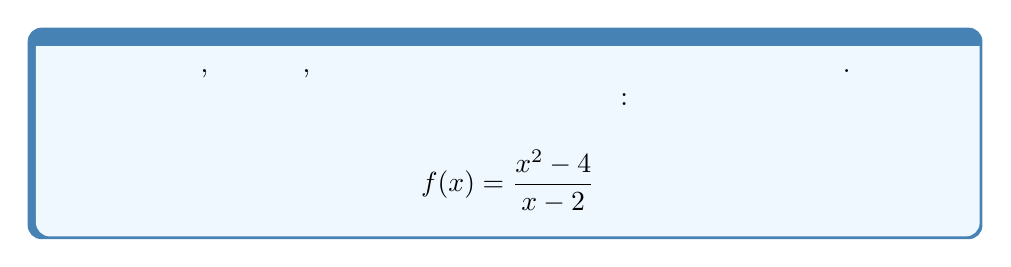What is the answer to this math problem? Для определения области определения и области значений данной рациональной функции выполним следующие шаги:

1. Область определения:
   Рациональная функция определена для всех значений $x$, кроме тех, при которых знаменатель равен нулю.
   
   Приравняем знаменатель к нулю:
   $x - 2 = 0$
   $x = 2$
   
   Таким образом, функция определена для всех действительных чисел, кроме 2.

2. Область значений:
   Преобразуем функцию, разделив числитель на знаменатель:
   
   $$\frac{x^2 - 4}{x - 2} = \frac{(x+2)(x-2)}{x-2} = x + 2$$
   
   Заметим, что после сокращения получилась линейная функция $y = x + 2$.
   
   Линейная функция может принимать любые действительные значения, кроме случая, когда $x = 2$ (так как это значение исключено из области определения исходной функции).

   При $x \to 2^-$ (приближение к 2 слева), $y \to 4^-$
   При $x \to 2^+$ (приближение к 2 справа), $y \to 4^+$

   Таким образом, функция может принимать любые действительные значения, кроме 4.
Answer: Область определения: $\{x \in \mathbb{R} : x \neq 2\}$
Область значений: $\{y \in \mathbb{R} : y \neq 4\}$ 